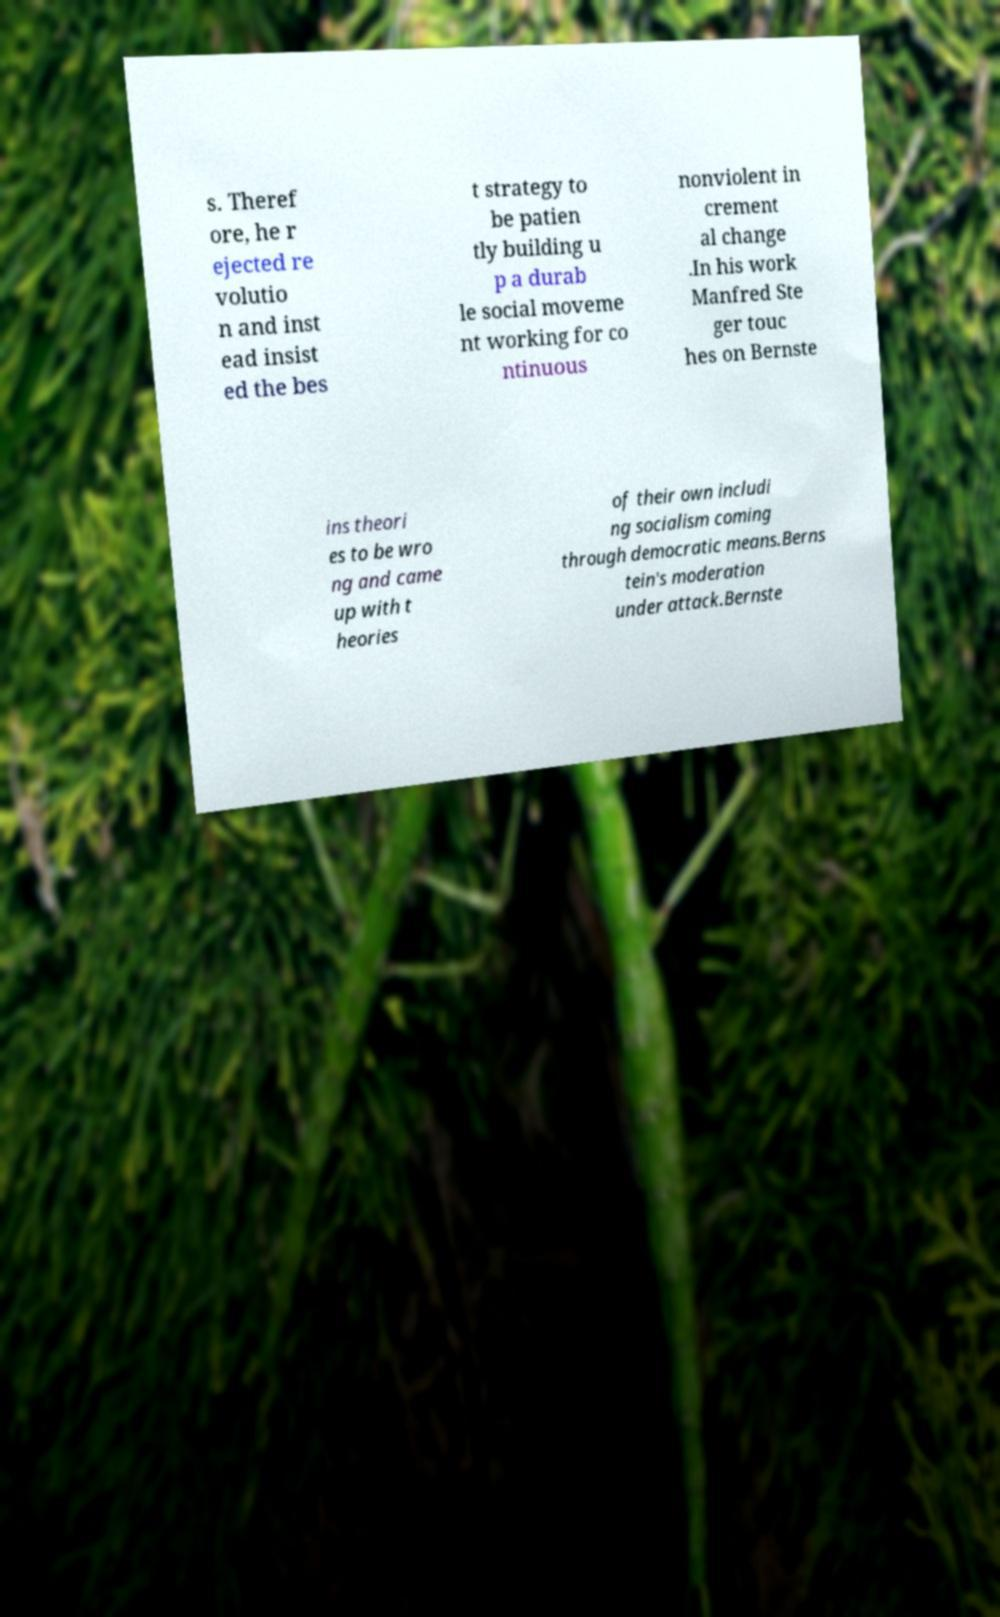Can you read and provide the text displayed in the image?This photo seems to have some interesting text. Can you extract and type it out for me? s. Theref ore, he r ejected re volutio n and inst ead insist ed the bes t strategy to be patien tly building u p a durab le social moveme nt working for co ntinuous nonviolent in crement al change .In his work Manfred Ste ger touc hes on Bernste ins theori es to be wro ng and came up with t heories of their own includi ng socialism coming through democratic means.Berns tein's moderation under attack.Bernste 